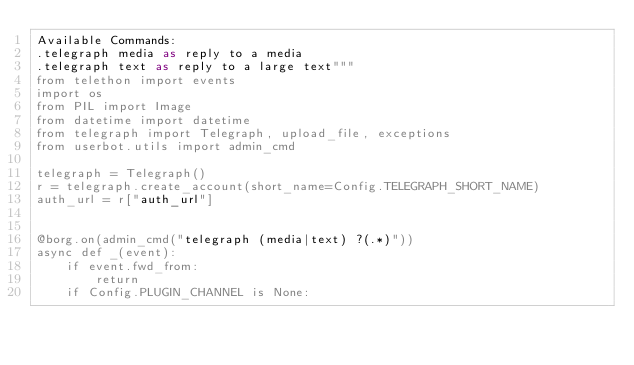Convert code to text. <code><loc_0><loc_0><loc_500><loc_500><_Python_>Available Commands:
.telegraph media as reply to a media
.telegraph text as reply to a large text"""
from telethon import events
import os
from PIL import Image
from datetime import datetime
from telegraph import Telegraph, upload_file, exceptions
from userbot.utils import admin_cmd

telegraph = Telegraph()
r = telegraph.create_account(short_name=Config.TELEGRAPH_SHORT_NAME)
auth_url = r["auth_url"]


@borg.on(admin_cmd("telegraph (media|text) ?(.*)"))
async def _(event):
    if event.fwd_from:
        return
    if Config.PLUGIN_CHANNEL is None:</code> 